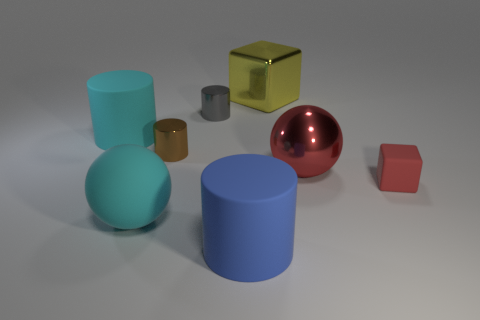Are there fewer matte cubes than large purple matte objects?
Provide a short and direct response. No. What is the small thing that is behind the tiny brown cylinder made of?
Offer a terse response. Metal. There is a yellow object that is the same size as the blue matte cylinder; what is it made of?
Make the answer very short. Metal. What material is the cyan object right of the matte object behind the small cylinder in front of the tiny gray cylinder made of?
Your response must be concise. Rubber. Is the size of the cyan thing in front of the brown cylinder the same as the big red ball?
Make the answer very short. Yes. Is the number of large metal blocks greater than the number of green matte cylinders?
Provide a short and direct response. Yes. What number of big objects are either blue rubber cylinders or gray objects?
Offer a very short reply. 1. What number of other things are the same color as the big metal cube?
Offer a terse response. 0. What number of big yellow spheres are the same material as the tiny brown cylinder?
Keep it short and to the point. 0. Does the cylinder that is in front of the red rubber object have the same color as the small rubber block?
Your response must be concise. No. 